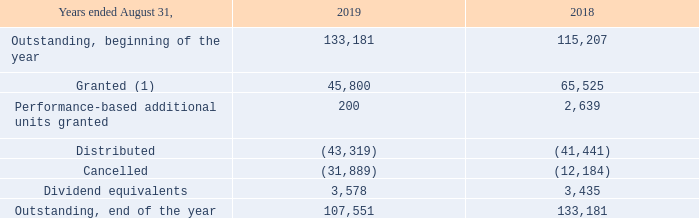PSU plan
The Corporation also offers a Performance Share Unit ("PSU") Plan for the benefit of its executive officers and designated employees. The objectives of the PSU Plan are to retain executive officers and designated employees, to align their interests with those of the shareholders and to sustain positive corporate performance, as measured by an economic value creation formula, a performance measure used by management.
The number of PSUs is based on the dollar value of the award and the average closing stock price of the Corporation for the previous twelve month period ending August 31. The PSUs vest over a three-year less one day period, based on the level of increase in the economic value of the Corporation or the relevant subsidiary for the preceding three-year period ending August 31, meaning that no vesting will occur if there is no increase in the economic value.
The participants are entitled to receive dividend equivalents in the form of additional PSUs but only with respect to vested PSUs. PSUs are redeemable in case of death, permanent disability, normal retirement or termination of employment not for cause, in which cases, the holder of PSUs is entitled to payment of the PSUs in proportion to the time of employment from the date of the grant to the date of termination versus the three-year less one day vesting period.
A trust was created for the purpose of purchasing these shares on the stock market in order to protect against stock price fluctuation and the Corporation instructed the trustee to purchase subordinate voting shares of the Corporation on the stock market. These shares are purchased and are held in trust for the participants until they are fully vested. The trust, considered as a special purpose entity, is consolidated in the Corporation’s financial statements with the value of the acquired subordinate voting shares held in trust under the PSU Plan presented in reduction of share capital.
Under the PSU Plan, the following PSUs were granted by the Corporation and are outstanding at August 31: Years ended August 31, 2019
(1) For the year ended August 31, 2019, the Corporation granted 14,625 (19,025 in 2018) PSUs to Cogeco's executive officers as executive officers of the Corporation.
A compensation expense of $1,400,000 ($2,198,000 in 2018) was recorded for the year ended August 31, 2019 related to this plan.
What are the objectives of the PSU plans? The objectives of the psu plan are to retain executive officers and designated employees, to align their interests with those of the shareholders and to sustain positive corporate performance, as measured by an economic value creation formula, a performance measure used by management. How is the number of PSUs calculated? The number of psus is based on the dollar value of the award and the average closing stock price of the corporation for the previous twelve month period ending august 31. How many PSUs were granted for the year ended August 31, 2019? 14,625. What is the increase / (decrease) in the granted from 2018 to 2019? 45,800 - 65,525
Answer: -19725. What is the average Performance-based additional units granted from 2018 to 2019? (200 + 2,639) / 2
Answer: 1419.5. What is the average distributed from 2018 to 2019? -(43,319 + 41,441) / 2
Answer: -42380. 